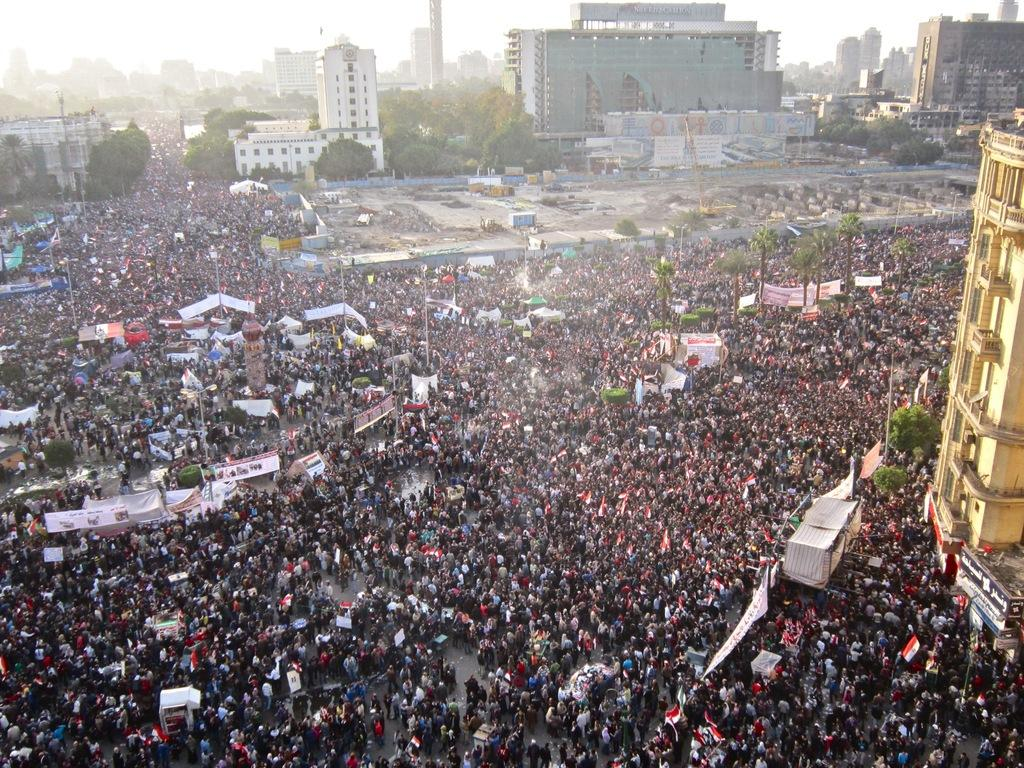How many people are in the group that is visible in the image? There is a group of people standing in the image, but the exact number cannot be determined from the provided facts. What is hanging from the poles in the image? There are banners in the image, which are likely hanging from the poles. What type of natural vegetation can be seen in the image? Trees are visible in the image. What type of structures are present in the image? There are buildings in the image. What type of insurance policy is being advertised on the shirt of the person in the image? There is no shirt or insurance policy mentioned in the image; it only features a group of people, banners, trees, poles, and buildings. 